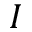<formula> <loc_0><loc_0><loc_500><loc_500>I</formula> 